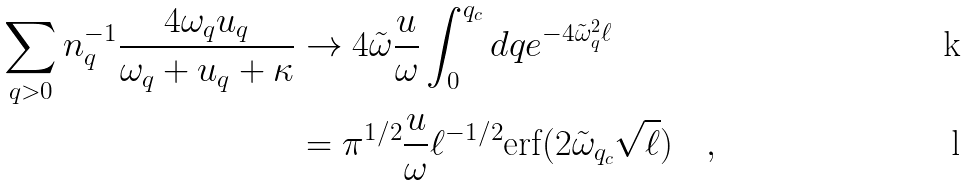Convert formula to latex. <formula><loc_0><loc_0><loc_500><loc_500>\sum _ { q > 0 } n _ { q } ^ { - 1 } \frac { 4 \omega _ { q } u _ { q } } { \omega _ { q } + u _ { q } + \kappa } & \to 4 \tilde { \omega } \frac { u } { \omega } \int _ { 0 } ^ { q _ { c } } d q e ^ { - 4 \tilde { \omega } _ { q } ^ { 2 } \ell } \\ & = \pi ^ { 1 / 2 } \frac { u } { \omega } \ell ^ { - 1 / 2 } \text {erf} ( 2 \tilde { \omega } _ { q _ { c } } \sqrt { \ell } ) \quad ,</formula> 